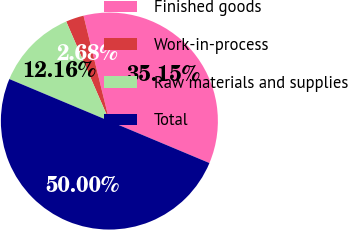<chart> <loc_0><loc_0><loc_500><loc_500><pie_chart><fcel>Finished goods<fcel>Work-in-process<fcel>Raw materials and supplies<fcel>Total<nl><fcel>35.15%<fcel>2.68%<fcel>12.16%<fcel>50.0%<nl></chart> 